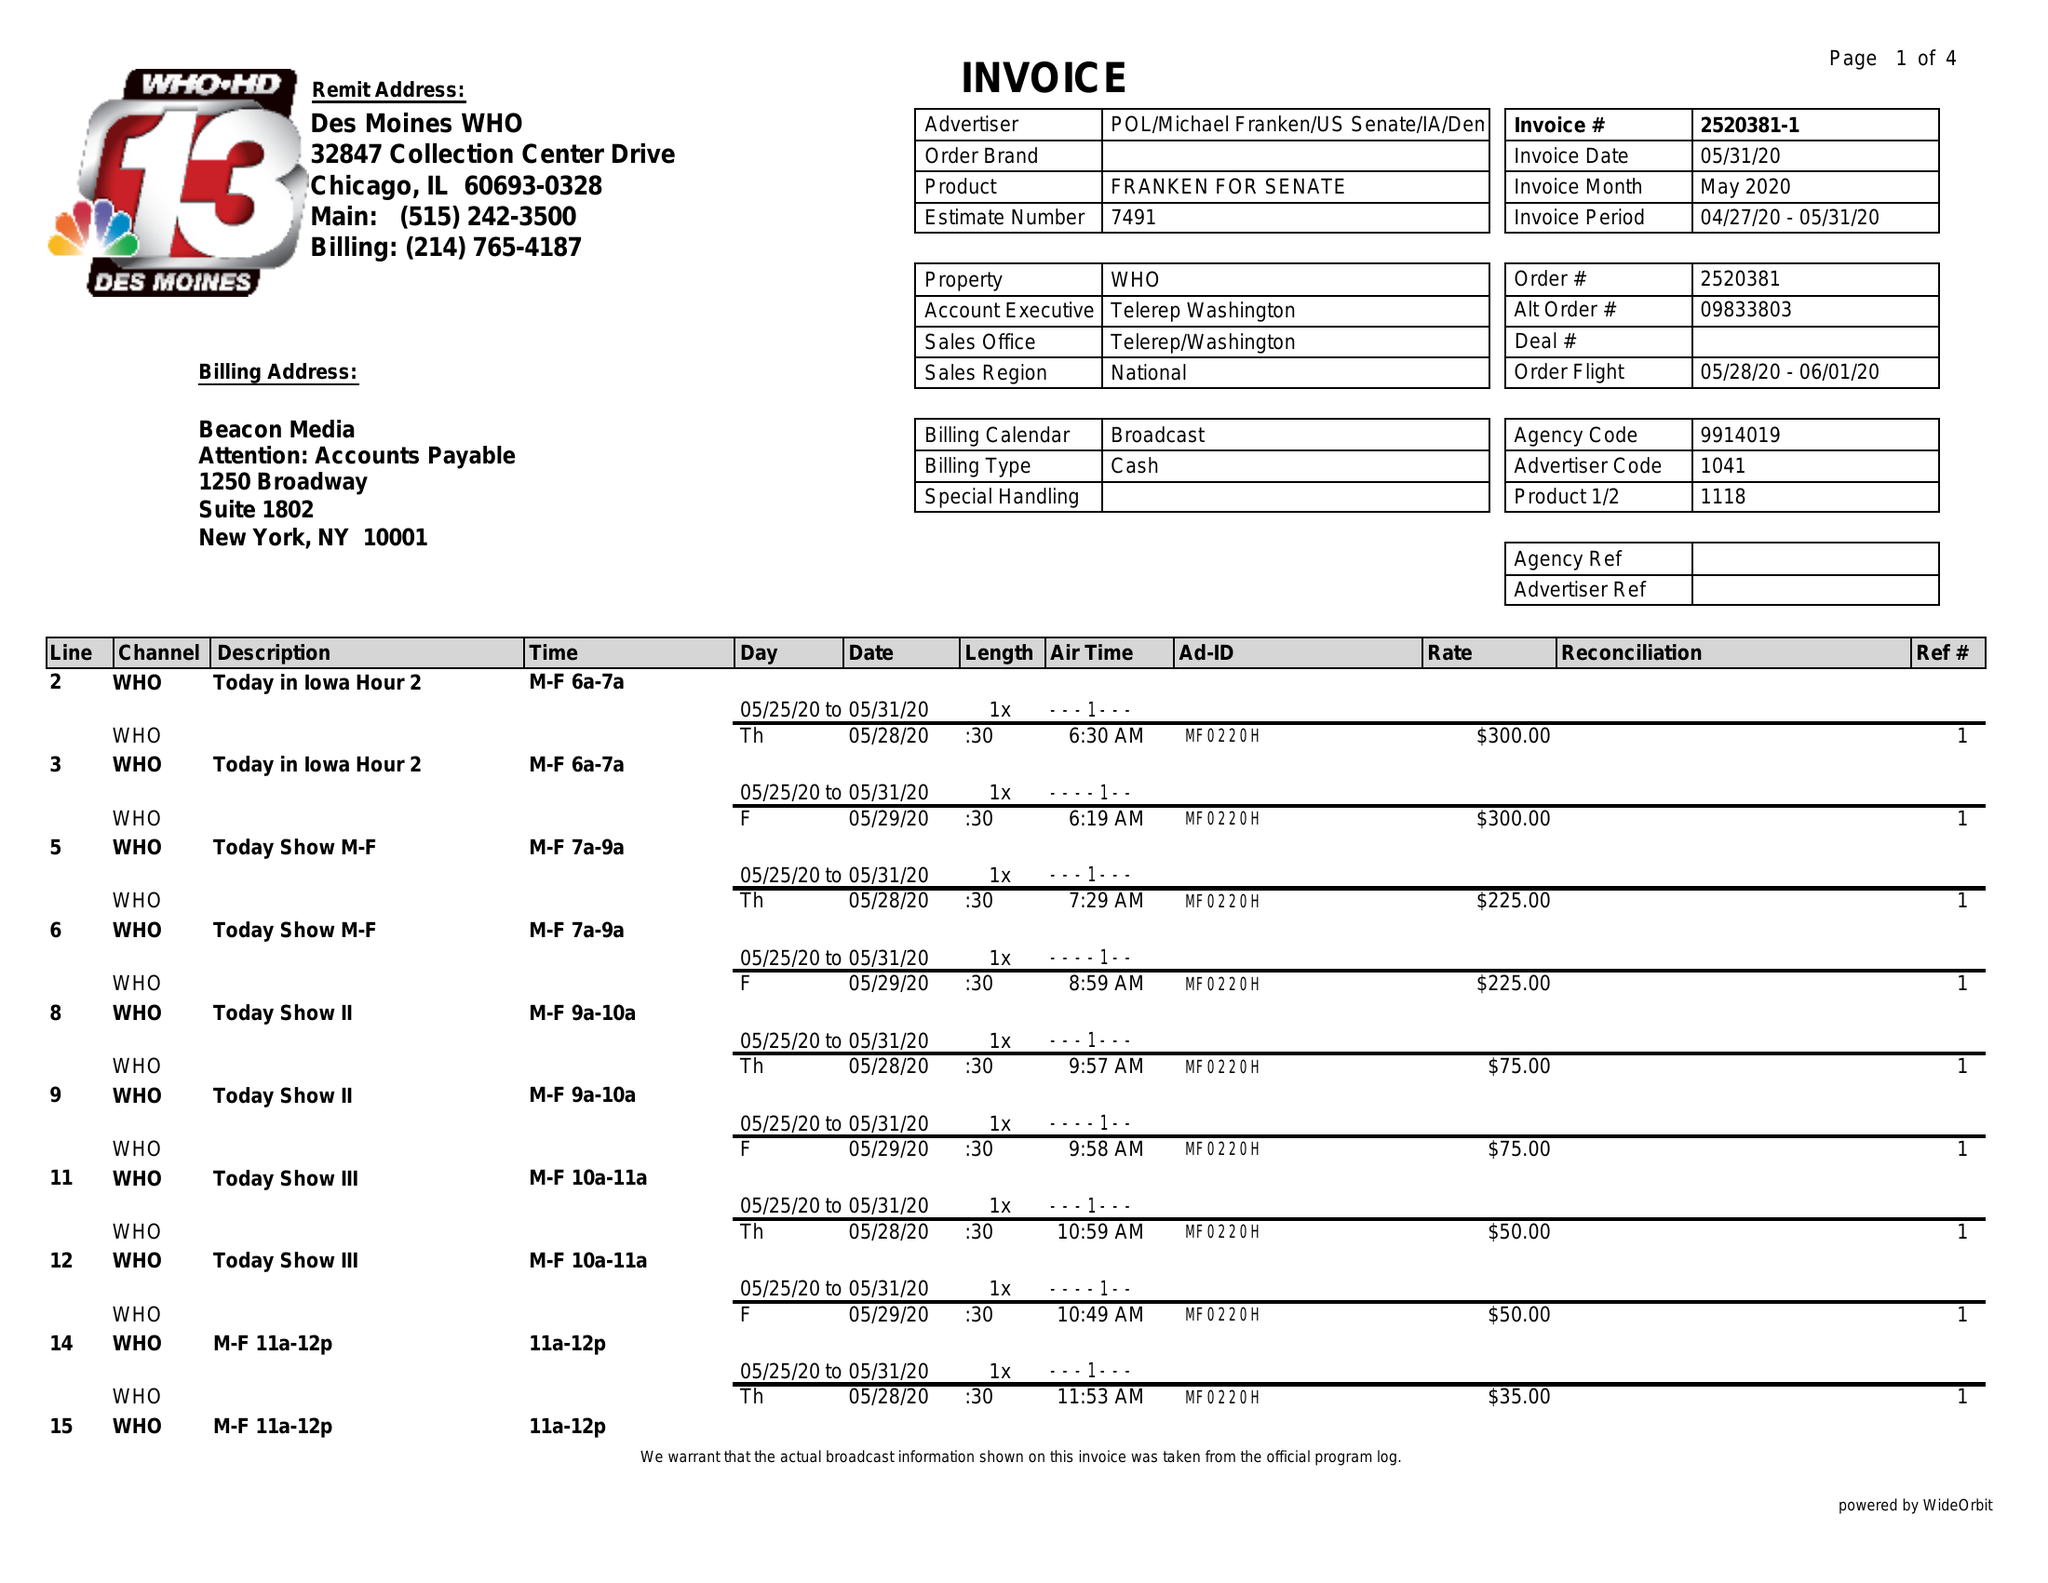What is the value for the advertiser?
Answer the question using a single word or phrase. POL/MICHAELFRANKEN/USSENATE/IA/DEM 